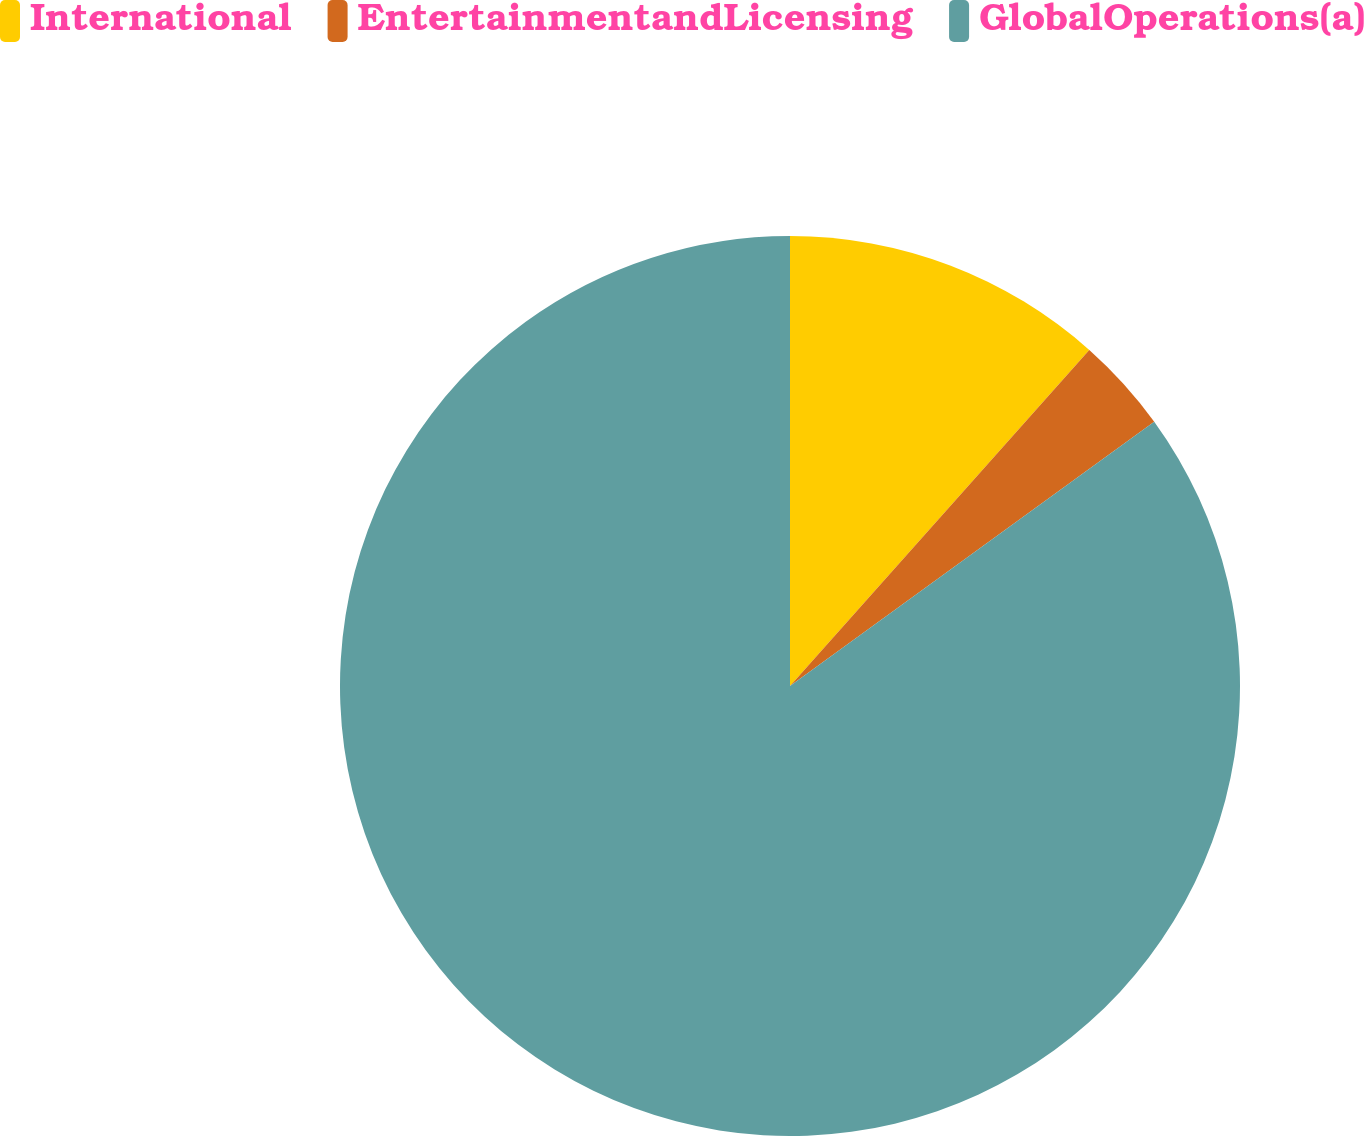Convert chart to OTSL. <chart><loc_0><loc_0><loc_500><loc_500><pie_chart><fcel>International<fcel>EntertainmentandLicensing<fcel>GlobalOperations(a)<nl><fcel>11.58%<fcel>3.43%<fcel>84.99%<nl></chart> 